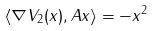<formula> <loc_0><loc_0><loc_500><loc_500>\langle \nabla V _ { 2 } ( x ) , A x \rangle = - \| x \| ^ { 2 }</formula> 